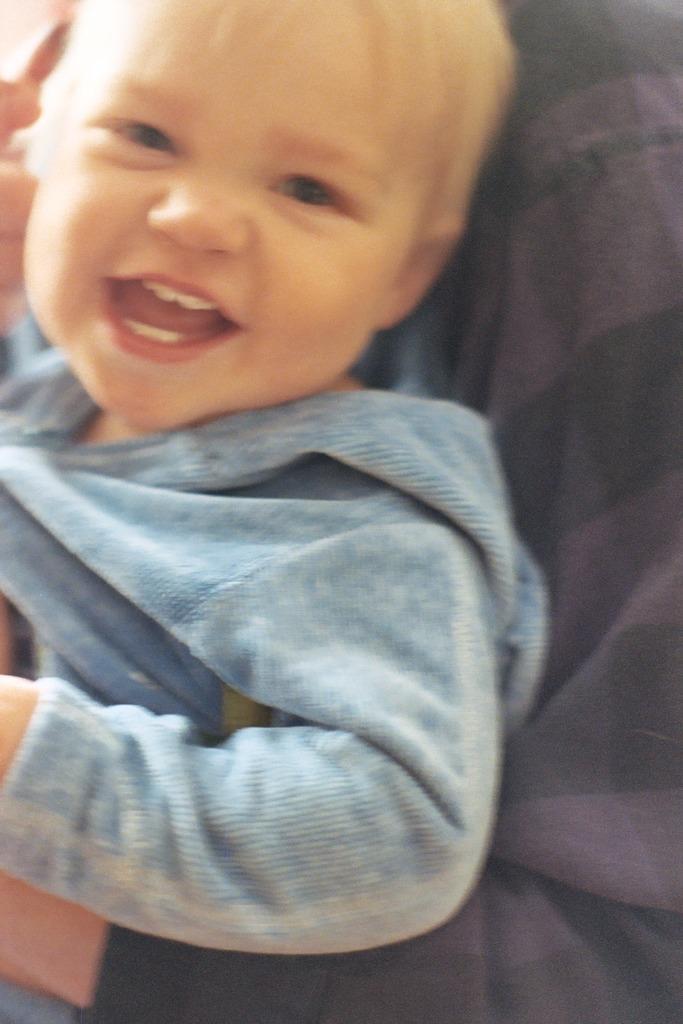Describe this image in one or two sentences. There is a person holding a baby. And the baby is smiling. 